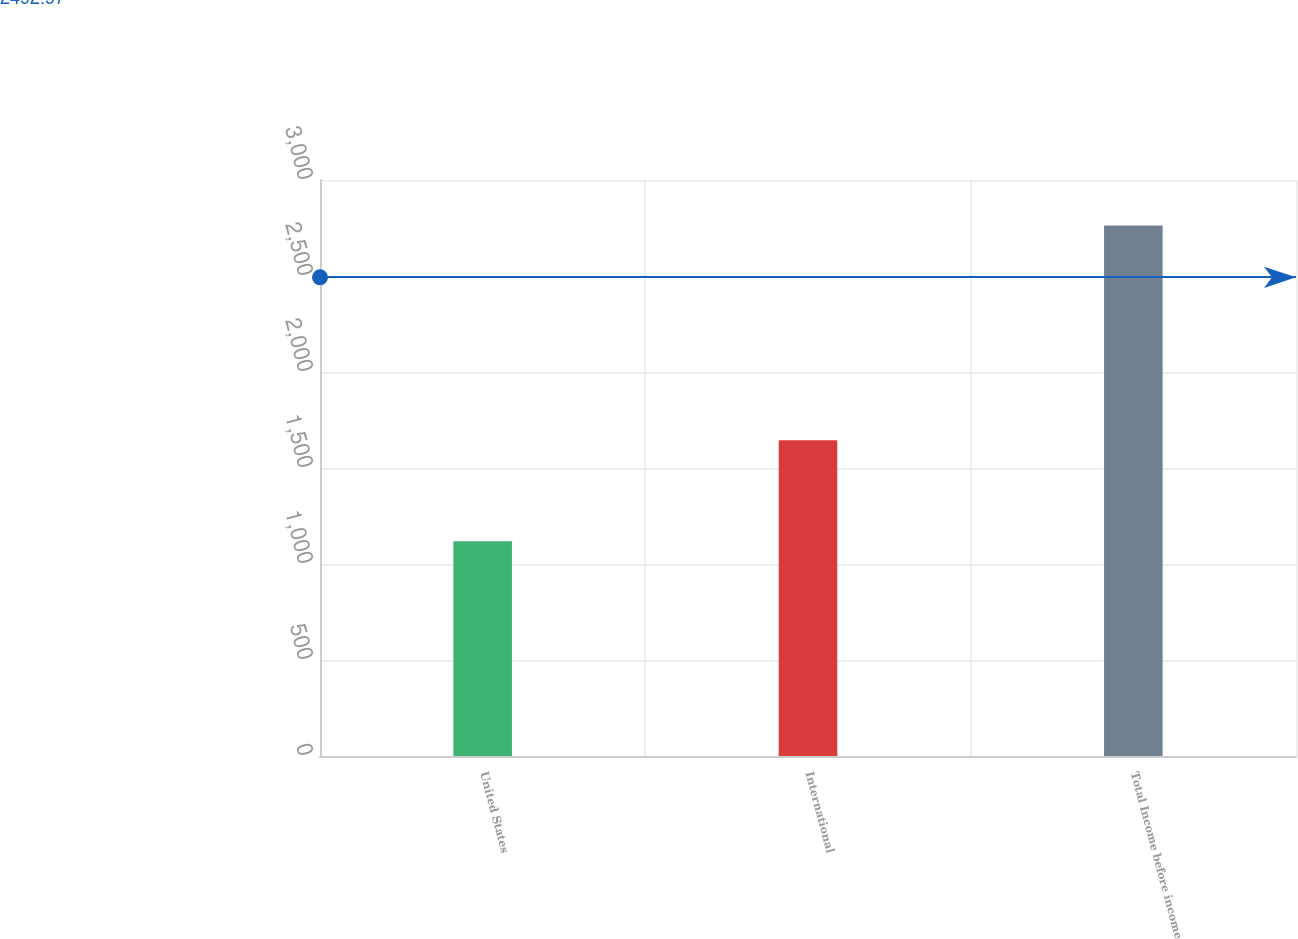<chart> <loc_0><loc_0><loc_500><loc_500><bar_chart><fcel>United States<fcel>International<fcel>Total Income before income<nl><fcel>1118<fcel>1645<fcel>2763<nl></chart> 